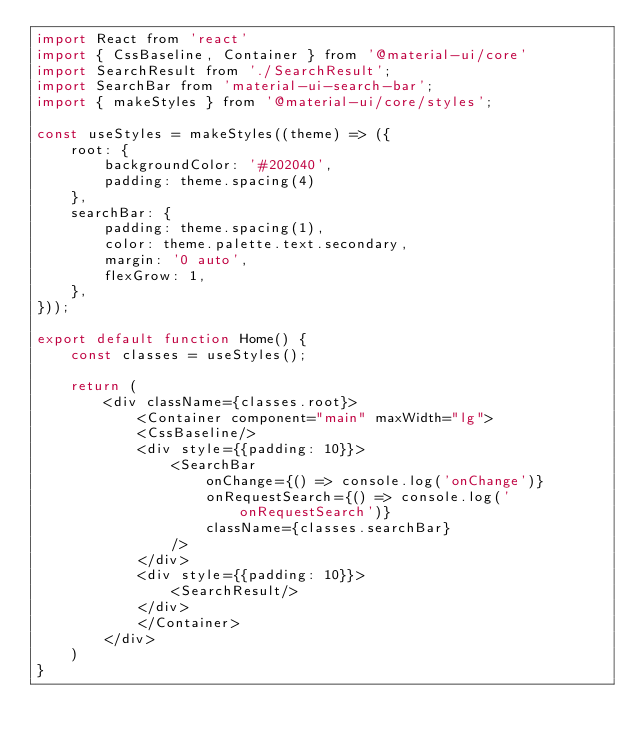<code> <loc_0><loc_0><loc_500><loc_500><_JavaScript_>import React from 'react'
import { CssBaseline, Container } from '@material-ui/core'
import SearchResult from './SearchResult';
import SearchBar from 'material-ui-search-bar';
import { makeStyles } from '@material-ui/core/styles';

const useStyles = makeStyles((theme) => ({
    root: {
        backgroundColor: '#202040',
        padding: theme.spacing(4)
    },    
    searchBar: {
        padding: theme.spacing(1),
        color: theme.palette.text.secondary,
        margin: '0 auto',
        flexGrow: 1,
    },
}));

export default function Home() {
    const classes = useStyles();

    return (
        <div className={classes.root}>
            <Container component="main" maxWidth="lg">
            <CssBaseline/>
            <div style={{padding: 10}}>
                <SearchBar
                    onChange={() => console.log('onChange')}
                    onRequestSearch={() => console.log('onRequestSearch')}
                    className={classes.searchBar}
                />
            </div>
            <div style={{padding: 10}}>
                <SearchResult/>
            </div>
            </Container>
        </div>
    )
}
</code> 